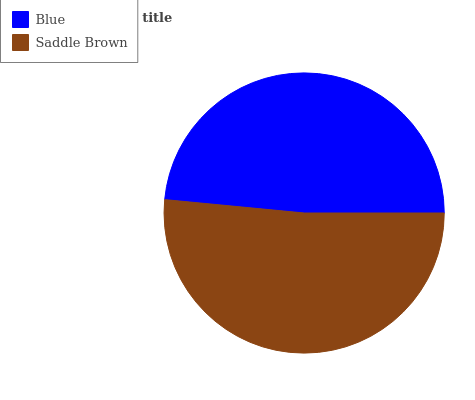Is Blue the minimum?
Answer yes or no. Yes. Is Saddle Brown the maximum?
Answer yes or no. Yes. Is Saddle Brown the minimum?
Answer yes or no. No. Is Saddle Brown greater than Blue?
Answer yes or no. Yes. Is Blue less than Saddle Brown?
Answer yes or no. Yes. Is Blue greater than Saddle Brown?
Answer yes or no. No. Is Saddle Brown less than Blue?
Answer yes or no. No. Is Saddle Brown the high median?
Answer yes or no. Yes. Is Blue the low median?
Answer yes or no. Yes. Is Blue the high median?
Answer yes or no. No. Is Saddle Brown the low median?
Answer yes or no. No. 